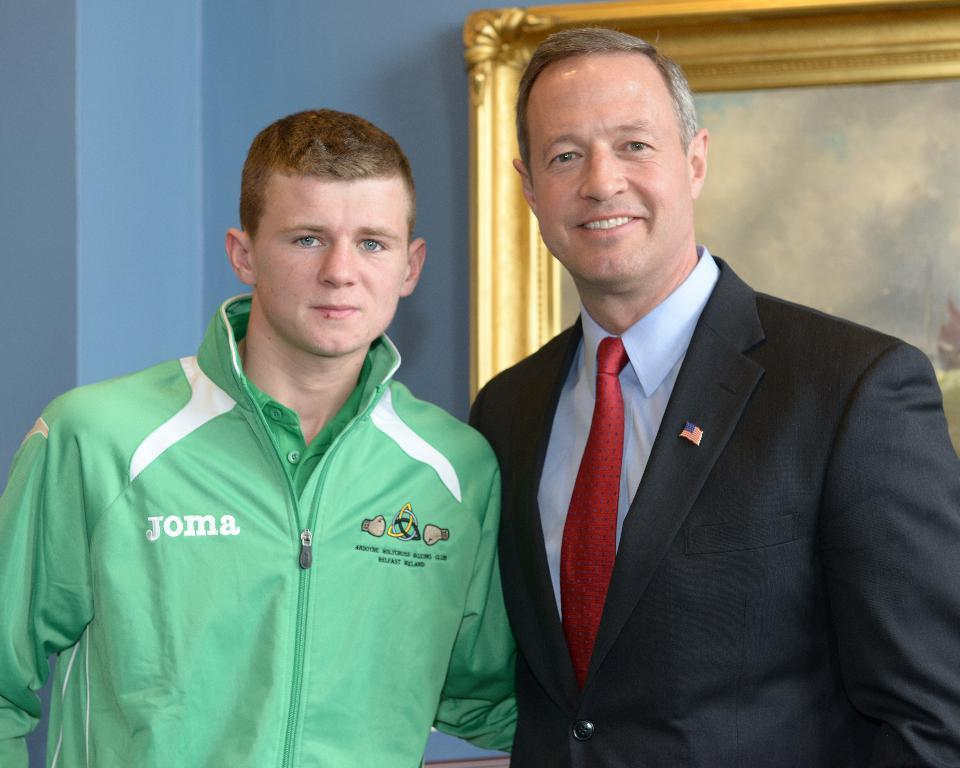<image>
Offer a succinct explanation of the picture presented. Man posing for a photo while wearing a green blazer that says JOMA. 